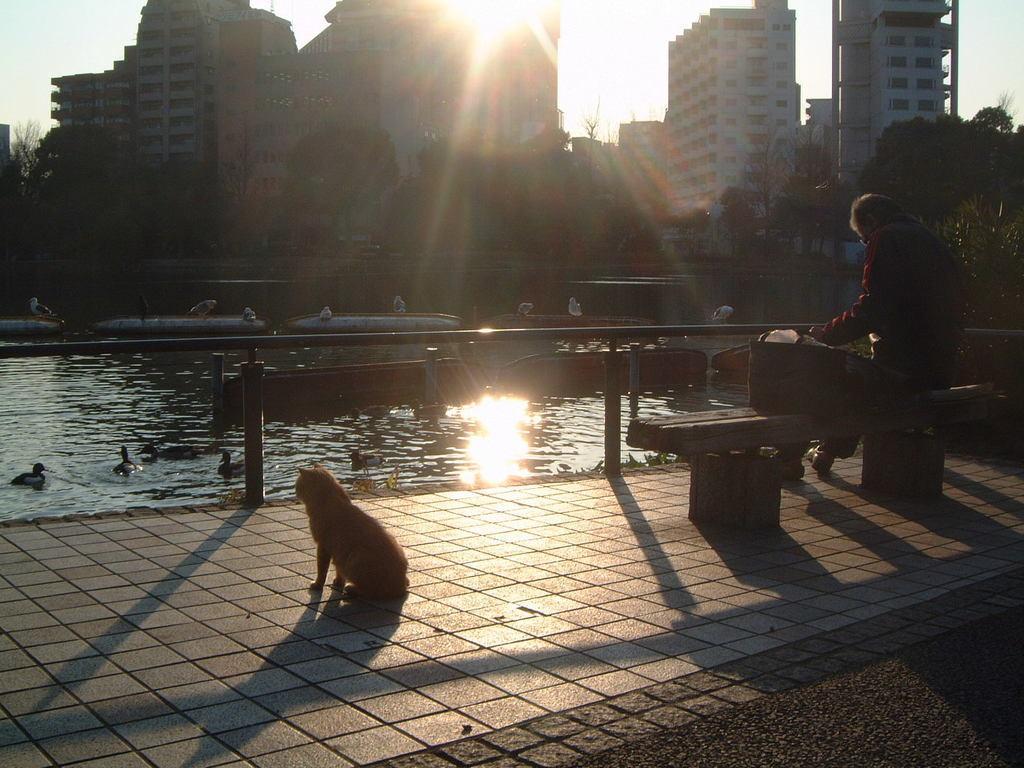In one or two sentences, can you explain what this image depicts? In the center of the image we can see the boats and ducks are present on the water. In the background of the image we can see the buildings, trees, railing. On the right side of the image we can see a person is sitting on a bench. At the bottom of the image we can see the road, footpath and dog. At the top of the image we can see the sun is present in the sky. 